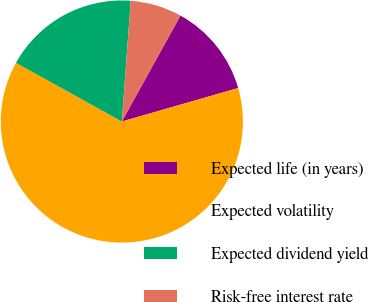Convert chart. <chart><loc_0><loc_0><loc_500><loc_500><pie_chart><fcel>Expected life (in years)<fcel>Expected volatility<fcel>Expected dividend yield<fcel>Risk-free interest rate<nl><fcel>12.5%<fcel>62.5%<fcel>18.12%<fcel>6.87%<nl></chart> 